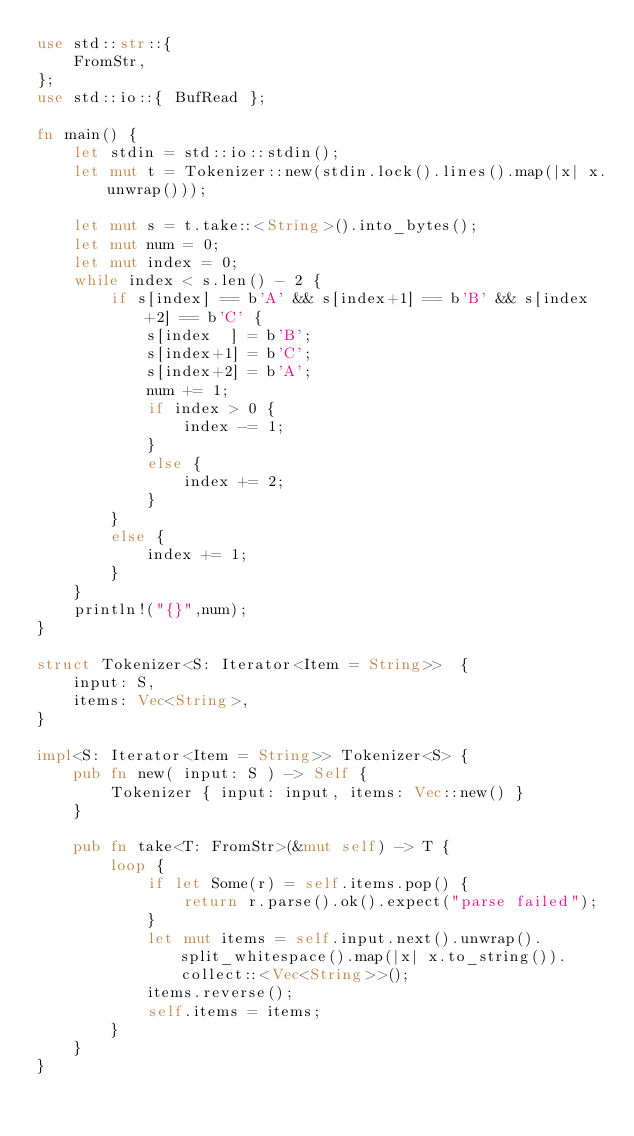Convert code to text. <code><loc_0><loc_0><loc_500><loc_500><_Rust_>use std::str::{
    FromStr,
};
use std::io::{ BufRead };

fn main() {
    let stdin = std::io::stdin();
    let mut t = Tokenizer::new(stdin.lock().lines().map(|x| x.unwrap()));

    let mut s = t.take::<String>().into_bytes();
    let mut num = 0;
    let mut index = 0;
    while index < s.len() - 2 {
        if s[index] == b'A' && s[index+1] == b'B' && s[index+2] == b'C' {
            s[index  ] = b'B';
            s[index+1] = b'C';
            s[index+2] = b'A';
            num += 1;
            if index > 0 {
                index -= 1;
            }
            else {
                index += 2;
            }
        }
        else {
            index += 1;
        }
    }
    println!("{}",num);
}

struct Tokenizer<S: Iterator<Item = String>>  {
    input: S,
    items: Vec<String>,
}

impl<S: Iterator<Item = String>> Tokenizer<S> {
    pub fn new( input: S ) -> Self {
        Tokenizer { input: input, items: Vec::new() }
    }

    pub fn take<T: FromStr>(&mut self) -> T {
        loop {
            if let Some(r) = self.items.pop() {
                return r.parse().ok().expect("parse failed");
            }
            let mut items = self.input.next().unwrap().split_whitespace().map(|x| x.to_string()).collect::<Vec<String>>();
            items.reverse();
            self.items = items;
        }
    }
}
</code> 